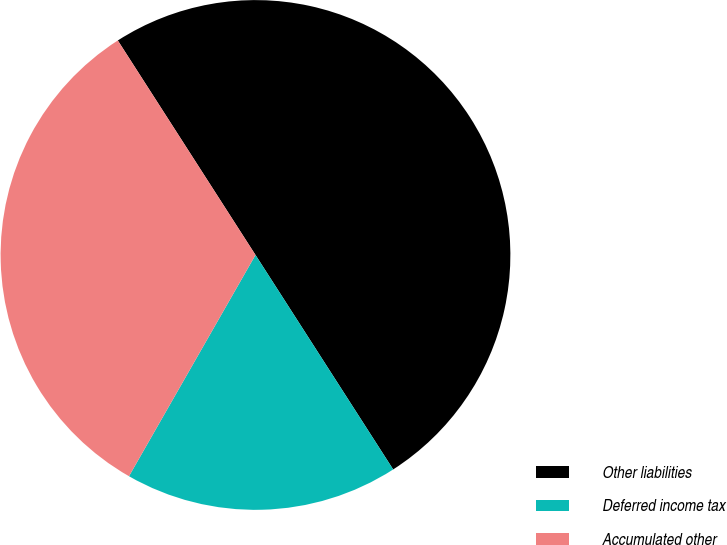Convert chart. <chart><loc_0><loc_0><loc_500><loc_500><pie_chart><fcel>Other liabilities<fcel>Deferred income tax<fcel>Accumulated other<nl><fcel>50.0%<fcel>17.35%<fcel>32.65%<nl></chart> 